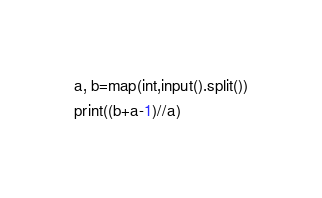Convert code to text. <code><loc_0><loc_0><loc_500><loc_500><_Python_>a, b=map(int,input().split())
print((b+a-1)//a)</code> 